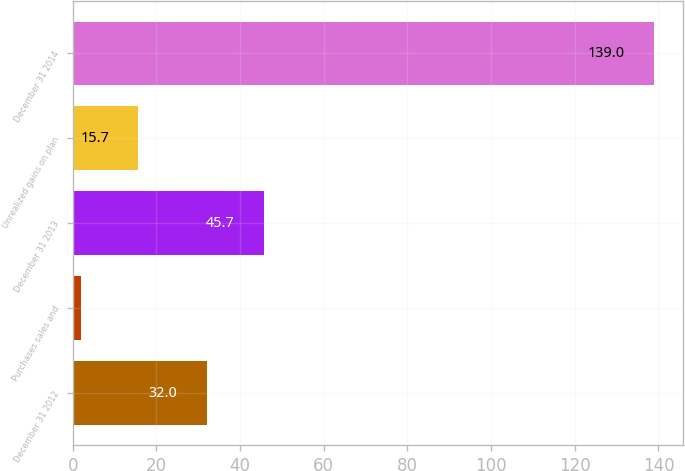Convert chart to OTSL. <chart><loc_0><loc_0><loc_500><loc_500><bar_chart><fcel>December 31 2012<fcel>Purchases sales and<fcel>December 31 2013<fcel>Unrealized gains on plan<fcel>December 31 2014<nl><fcel>32<fcel>2<fcel>45.7<fcel>15.7<fcel>139<nl></chart> 